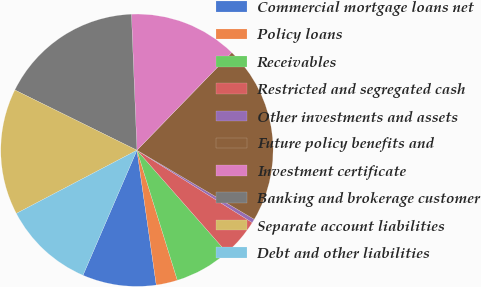Convert chart to OTSL. <chart><loc_0><loc_0><loc_500><loc_500><pie_chart><fcel>Commercial mortgage loans net<fcel>Policy loans<fcel>Receivables<fcel>Restricted and segregated cash<fcel>Other investments and assets<fcel>Future policy benefits and<fcel>Investment certificate<fcel>Banking and brokerage customer<fcel>Separate account liabilities<fcel>Debt and other liabilities<nl><fcel>8.75%<fcel>2.53%<fcel>6.68%<fcel>4.6%<fcel>0.45%<fcel>21.21%<fcel>12.91%<fcel>17.06%<fcel>14.98%<fcel>10.83%<nl></chart> 